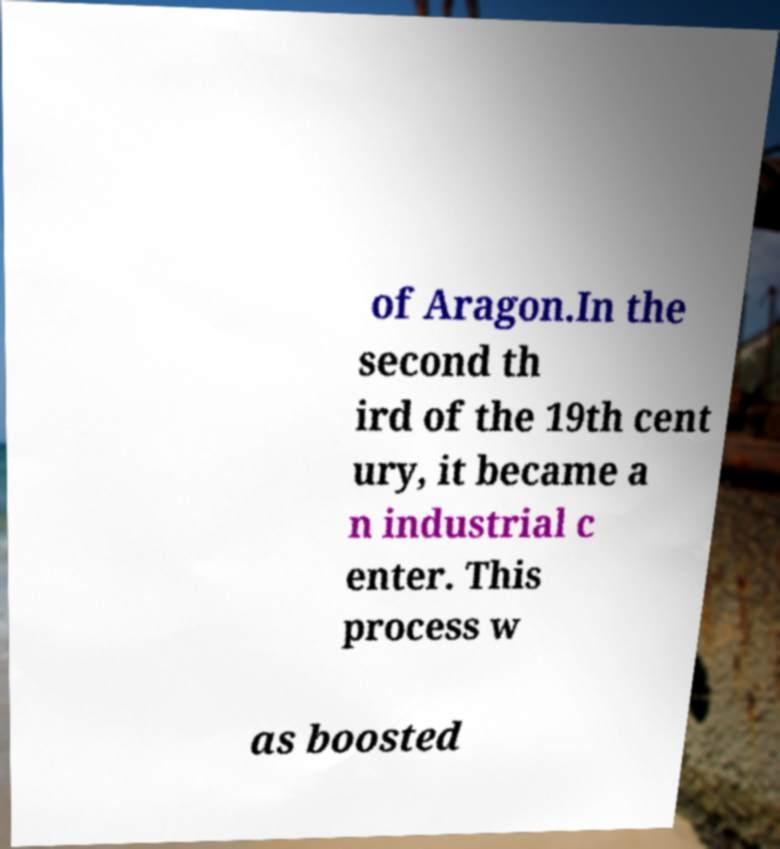Can you accurately transcribe the text from the provided image for me? of Aragon.In the second th ird of the 19th cent ury, it became a n industrial c enter. This process w as boosted 